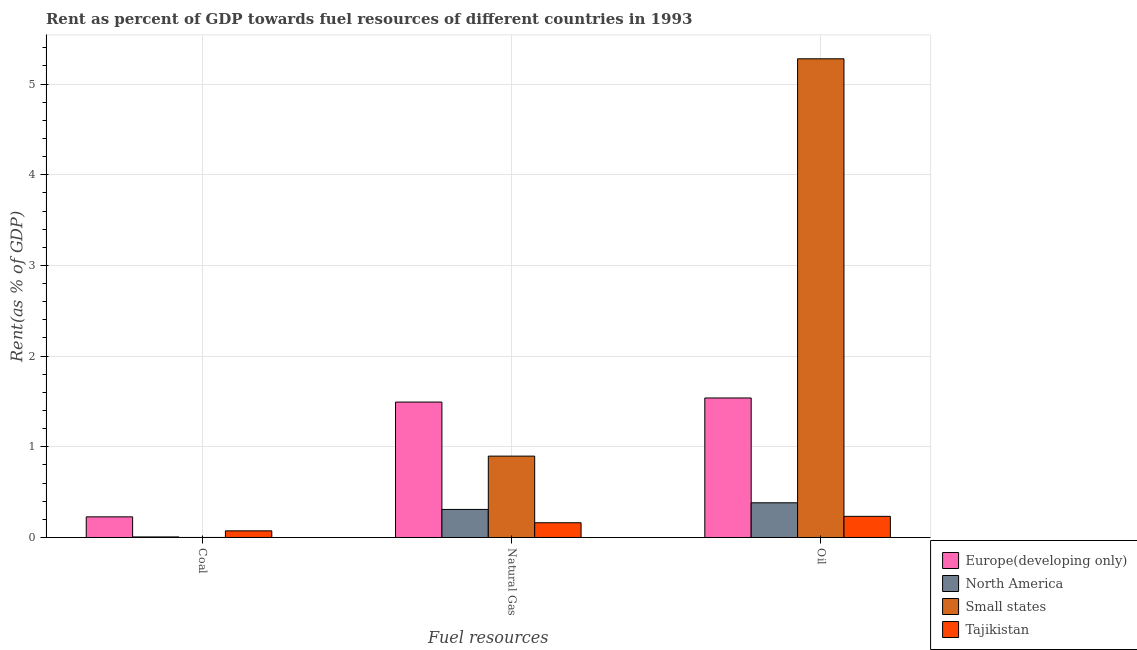How many groups of bars are there?
Make the answer very short. 3. How many bars are there on the 1st tick from the left?
Ensure brevity in your answer.  4. How many bars are there on the 3rd tick from the right?
Offer a terse response. 4. What is the label of the 1st group of bars from the left?
Offer a very short reply. Coal. What is the rent towards natural gas in North America?
Your answer should be very brief. 0.31. Across all countries, what is the maximum rent towards natural gas?
Give a very brief answer. 1.49. Across all countries, what is the minimum rent towards coal?
Keep it short and to the point. 0. In which country was the rent towards oil maximum?
Offer a very short reply. Small states. In which country was the rent towards natural gas minimum?
Your response must be concise. Tajikistan. What is the total rent towards oil in the graph?
Offer a very short reply. 7.43. What is the difference between the rent towards coal in North America and that in Small states?
Offer a very short reply. 0.01. What is the difference between the rent towards coal in Small states and the rent towards oil in Tajikistan?
Your answer should be very brief. -0.23. What is the average rent towards oil per country?
Give a very brief answer. 1.86. What is the difference between the rent towards natural gas and rent towards coal in North America?
Offer a very short reply. 0.3. In how many countries, is the rent towards natural gas greater than 3.2 %?
Offer a very short reply. 0. What is the ratio of the rent towards coal in Europe(developing only) to that in Small states?
Offer a terse response. 819.94. Is the difference between the rent towards natural gas in Europe(developing only) and Small states greater than the difference between the rent towards coal in Europe(developing only) and Small states?
Your answer should be compact. Yes. What is the difference between the highest and the second highest rent towards oil?
Ensure brevity in your answer.  3.74. What is the difference between the highest and the lowest rent towards oil?
Provide a succinct answer. 5.05. In how many countries, is the rent towards coal greater than the average rent towards coal taken over all countries?
Make the answer very short. 1. What does the 4th bar from the left in Oil represents?
Make the answer very short. Tajikistan. Is it the case that in every country, the sum of the rent towards coal and rent towards natural gas is greater than the rent towards oil?
Keep it short and to the point. No. Are all the bars in the graph horizontal?
Keep it short and to the point. No. What is the difference between two consecutive major ticks on the Y-axis?
Give a very brief answer. 1. Does the graph contain any zero values?
Your response must be concise. No. How many legend labels are there?
Give a very brief answer. 4. How are the legend labels stacked?
Provide a succinct answer. Vertical. What is the title of the graph?
Your answer should be compact. Rent as percent of GDP towards fuel resources of different countries in 1993. What is the label or title of the X-axis?
Ensure brevity in your answer.  Fuel resources. What is the label or title of the Y-axis?
Ensure brevity in your answer.  Rent(as % of GDP). What is the Rent(as % of GDP) in Europe(developing only) in Coal?
Offer a terse response. 0.23. What is the Rent(as % of GDP) in North America in Coal?
Give a very brief answer. 0.01. What is the Rent(as % of GDP) of Small states in Coal?
Provide a succinct answer. 0. What is the Rent(as % of GDP) of Tajikistan in Coal?
Give a very brief answer. 0.07. What is the Rent(as % of GDP) in Europe(developing only) in Natural Gas?
Give a very brief answer. 1.49. What is the Rent(as % of GDP) of North America in Natural Gas?
Make the answer very short. 0.31. What is the Rent(as % of GDP) of Small states in Natural Gas?
Your answer should be compact. 0.9. What is the Rent(as % of GDP) of Tajikistan in Natural Gas?
Your answer should be very brief. 0.16. What is the Rent(as % of GDP) in Europe(developing only) in Oil?
Offer a very short reply. 1.54. What is the Rent(as % of GDP) of North America in Oil?
Your response must be concise. 0.38. What is the Rent(as % of GDP) in Small states in Oil?
Offer a terse response. 5.28. What is the Rent(as % of GDP) in Tajikistan in Oil?
Give a very brief answer. 0.23. Across all Fuel resources, what is the maximum Rent(as % of GDP) of Europe(developing only)?
Give a very brief answer. 1.54. Across all Fuel resources, what is the maximum Rent(as % of GDP) of North America?
Offer a terse response. 0.38. Across all Fuel resources, what is the maximum Rent(as % of GDP) in Small states?
Your response must be concise. 5.28. Across all Fuel resources, what is the maximum Rent(as % of GDP) in Tajikistan?
Offer a very short reply. 0.23. Across all Fuel resources, what is the minimum Rent(as % of GDP) of Europe(developing only)?
Provide a short and direct response. 0.23. Across all Fuel resources, what is the minimum Rent(as % of GDP) in North America?
Give a very brief answer. 0.01. Across all Fuel resources, what is the minimum Rent(as % of GDP) in Small states?
Give a very brief answer. 0. Across all Fuel resources, what is the minimum Rent(as % of GDP) of Tajikistan?
Provide a short and direct response. 0.07. What is the total Rent(as % of GDP) of Europe(developing only) in the graph?
Ensure brevity in your answer.  3.26. What is the total Rent(as % of GDP) in North America in the graph?
Your answer should be very brief. 0.7. What is the total Rent(as % of GDP) of Small states in the graph?
Provide a succinct answer. 6.18. What is the total Rent(as % of GDP) in Tajikistan in the graph?
Ensure brevity in your answer.  0.47. What is the difference between the Rent(as % of GDP) of Europe(developing only) in Coal and that in Natural Gas?
Your answer should be compact. -1.27. What is the difference between the Rent(as % of GDP) of North America in Coal and that in Natural Gas?
Ensure brevity in your answer.  -0.3. What is the difference between the Rent(as % of GDP) of Small states in Coal and that in Natural Gas?
Keep it short and to the point. -0.9. What is the difference between the Rent(as % of GDP) of Tajikistan in Coal and that in Natural Gas?
Your answer should be very brief. -0.09. What is the difference between the Rent(as % of GDP) of Europe(developing only) in Coal and that in Oil?
Offer a terse response. -1.31. What is the difference between the Rent(as % of GDP) in North America in Coal and that in Oil?
Make the answer very short. -0.38. What is the difference between the Rent(as % of GDP) of Small states in Coal and that in Oil?
Offer a terse response. -5.28. What is the difference between the Rent(as % of GDP) of Tajikistan in Coal and that in Oil?
Make the answer very short. -0.16. What is the difference between the Rent(as % of GDP) of Europe(developing only) in Natural Gas and that in Oil?
Keep it short and to the point. -0.05. What is the difference between the Rent(as % of GDP) in North America in Natural Gas and that in Oil?
Keep it short and to the point. -0.07. What is the difference between the Rent(as % of GDP) in Small states in Natural Gas and that in Oil?
Make the answer very short. -4.38. What is the difference between the Rent(as % of GDP) of Tajikistan in Natural Gas and that in Oil?
Your answer should be compact. -0.07. What is the difference between the Rent(as % of GDP) in Europe(developing only) in Coal and the Rent(as % of GDP) in North America in Natural Gas?
Your answer should be very brief. -0.08. What is the difference between the Rent(as % of GDP) in Europe(developing only) in Coal and the Rent(as % of GDP) in Small states in Natural Gas?
Your answer should be very brief. -0.67. What is the difference between the Rent(as % of GDP) in Europe(developing only) in Coal and the Rent(as % of GDP) in Tajikistan in Natural Gas?
Ensure brevity in your answer.  0.07. What is the difference between the Rent(as % of GDP) in North America in Coal and the Rent(as % of GDP) in Small states in Natural Gas?
Provide a succinct answer. -0.89. What is the difference between the Rent(as % of GDP) of North America in Coal and the Rent(as % of GDP) of Tajikistan in Natural Gas?
Make the answer very short. -0.16. What is the difference between the Rent(as % of GDP) in Small states in Coal and the Rent(as % of GDP) in Tajikistan in Natural Gas?
Make the answer very short. -0.16. What is the difference between the Rent(as % of GDP) of Europe(developing only) in Coal and the Rent(as % of GDP) of North America in Oil?
Provide a short and direct response. -0.16. What is the difference between the Rent(as % of GDP) of Europe(developing only) in Coal and the Rent(as % of GDP) of Small states in Oil?
Ensure brevity in your answer.  -5.05. What is the difference between the Rent(as % of GDP) of Europe(developing only) in Coal and the Rent(as % of GDP) of Tajikistan in Oil?
Provide a short and direct response. -0.01. What is the difference between the Rent(as % of GDP) in North America in Coal and the Rent(as % of GDP) in Small states in Oil?
Provide a succinct answer. -5.27. What is the difference between the Rent(as % of GDP) in North America in Coal and the Rent(as % of GDP) in Tajikistan in Oil?
Offer a terse response. -0.23. What is the difference between the Rent(as % of GDP) of Small states in Coal and the Rent(as % of GDP) of Tajikistan in Oil?
Ensure brevity in your answer.  -0.23. What is the difference between the Rent(as % of GDP) of Europe(developing only) in Natural Gas and the Rent(as % of GDP) of North America in Oil?
Offer a terse response. 1.11. What is the difference between the Rent(as % of GDP) of Europe(developing only) in Natural Gas and the Rent(as % of GDP) of Small states in Oil?
Keep it short and to the point. -3.79. What is the difference between the Rent(as % of GDP) of Europe(developing only) in Natural Gas and the Rent(as % of GDP) of Tajikistan in Oil?
Ensure brevity in your answer.  1.26. What is the difference between the Rent(as % of GDP) of North America in Natural Gas and the Rent(as % of GDP) of Small states in Oil?
Keep it short and to the point. -4.97. What is the difference between the Rent(as % of GDP) of North America in Natural Gas and the Rent(as % of GDP) of Tajikistan in Oil?
Your answer should be very brief. 0.08. What is the difference between the Rent(as % of GDP) in Small states in Natural Gas and the Rent(as % of GDP) in Tajikistan in Oil?
Keep it short and to the point. 0.66. What is the average Rent(as % of GDP) of Europe(developing only) per Fuel resources?
Provide a short and direct response. 1.09. What is the average Rent(as % of GDP) in North America per Fuel resources?
Provide a short and direct response. 0.23. What is the average Rent(as % of GDP) in Small states per Fuel resources?
Offer a very short reply. 2.06. What is the average Rent(as % of GDP) of Tajikistan per Fuel resources?
Offer a terse response. 0.16. What is the difference between the Rent(as % of GDP) in Europe(developing only) and Rent(as % of GDP) in North America in Coal?
Provide a succinct answer. 0.22. What is the difference between the Rent(as % of GDP) of Europe(developing only) and Rent(as % of GDP) of Small states in Coal?
Your response must be concise. 0.23. What is the difference between the Rent(as % of GDP) of Europe(developing only) and Rent(as % of GDP) of Tajikistan in Coal?
Make the answer very short. 0.15. What is the difference between the Rent(as % of GDP) in North America and Rent(as % of GDP) in Small states in Coal?
Keep it short and to the point. 0.01. What is the difference between the Rent(as % of GDP) of North America and Rent(as % of GDP) of Tajikistan in Coal?
Provide a short and direct response. -0.07. What is the difference between the Rent(as % of GDP) in Small states and Rent(as % of GDP) in Tajikistan in Coal?
Your response must be concise. -0.07. What is the difference between the Rent(as % of GDP) of Europe(developing only) and Rent(as % of GDP) of North America in Natural Gas?
Your response must be concise. 1.18. What is the difference between the Rent(as % of GDP) in Europe(developing only) and Rent(as % of GDP) in Small states in Natural Gas?
Offer a terse response. 0.6. What is the difference between the Rent(as % of GDP) of Europe(developing only) and Rent(as % of GDP) of Tajikistan in Natural Gas?
Make the answer very short. 1.33. What is the difference between the Rent(as % of GDP) of North America and Rent(as % of GDP) of Small states in Natural Gas?
Your answer should be very brief. -0.59. What is the difference between the Rent(as % of GDP) in North America and Rent(as % of GDP) in Tajikistan in Natural Gas?
Give a very brief answer. 0.15. What is the difference between the Rent(as % of GDP) in Small states and Rent(as % of GDP) in Tajikistan in Natural Gas?
Make the answer very short. 0.73. What is the difference between the Rent(as % of GDP) in Europe(developing only) and Rent(as % of GDP) in North America in Oil?
Provide a succinct answer. 1.16. What is the difference between the Rent(as % of GDP) of Europe(developing only) and Rent(as % of GDP) of Small states in Oil?
Keep it short and to the point. -3.74. What is the difference between the Rent(as % of GDP) in Europe(developing only) and Rent(as % of GDP) in Tajikistan in Oil?
Your answer should be compact. 1.31. What is the difference between the Rent(as % of GDP) of North America and Rent(as % of GDP) of Small states in Oil?
Keep it short and to the point. -4.9. What is the difference between the Rent(as % of GDP) of North America and Rent(as % of GDP) of Tajikistan in Oil?
Ensure brevity in your answer.  0.15. What is the difference between the Rent(as % of GDP) of Small states and Rent(as % of GDP) of Tajikistan in Oil?
Make the answer very short. 5.05. What is the ratio of the Rent(as % of GDP) of Europe(developing only) in Coal to that in Natural Gas?
Give a very brief answer. 0.15. What is the ratio of the Rent(as % of GDP) in North America in Coal to that in Natural Gas?
Your answer should be compact. 0.02. What is the ratio of the Rent(as % of GDP) in Small states in Coal to that in Natural Gas?
Give a very brief answer. 0. What is the ratio of the Rent(as % of GDP) in Tajikistan in Coal to that in Natural Gas?
Keep it short and to the point. 0.45. What is the ratio of the Rent(as % of GDP) in Europe(developing only) in Coal to that in Oil?
Your answer should be compact. 0.15. What is the ratio of the Rent(as % of GDP) in North America in Coal to that in Oil?
Give a very brief answer. 0.02. What is the ratio of the Rent(as % of GDP) in Small states in Coal to that in Oil?
Ensure brevity in your answer.  0. What is the ratio of the Rent(as % of GDP) in Tajikistan in Coal to that in Oil?
Offer a terse response. 0.31. What is the ratio of the Rent(as % of GDP) in Europe(developing only) in Natural Gas to that in Oil?
Your answer should be very brief. 0.97. What is the ratio of the Rent(as % of GDP) in North America in Natural Gas to that in Oil?
Offer a terse response. 0.81. What is the ratio of the Rent(as % of GDP) in Small states in Natural Gas to that in Oil?
Provide a short and direct response. 0.17. What is the ratio of the Rent(as % of GDP) of Tajikistan in Natural Gas to that in Oil?
Keep it short and to the point. 0.7. What is the difference between the highest and the second highest Rent(as % of GDP) of Europe(developing only)?
Offer a terse response. 0.05. What is the difference between the highest and the second highest Rent(as % of GDP) in North America?
Give a very brief answer. 0.07. What is the difference between the highest and the second highest Rent(as % of GDP) in Small states?
Provide a succinct answer. 4.38. What is the difference between the highest and the second highest Rent(as % of GDP) in Tajikistan?
Offer a terse response. 0.07. What is the difference between the highest and the lowest Rent(as % of GDP) in Europe(developing only)?
Provide a succinct answer. 1.31. What is the difference between the highest and the lowest Rent(as % of GDP) of North America?
Your answer should be very brief. 0.38. What is the difference between the highest and the lowest Rent(as % of GDP) in Small states?
Provide a short and direct response. 5.28. What is the difference between the highest and the lowest Rent(as % of GDP) in Tajikistan?
Make the answer very short. 0.16. 